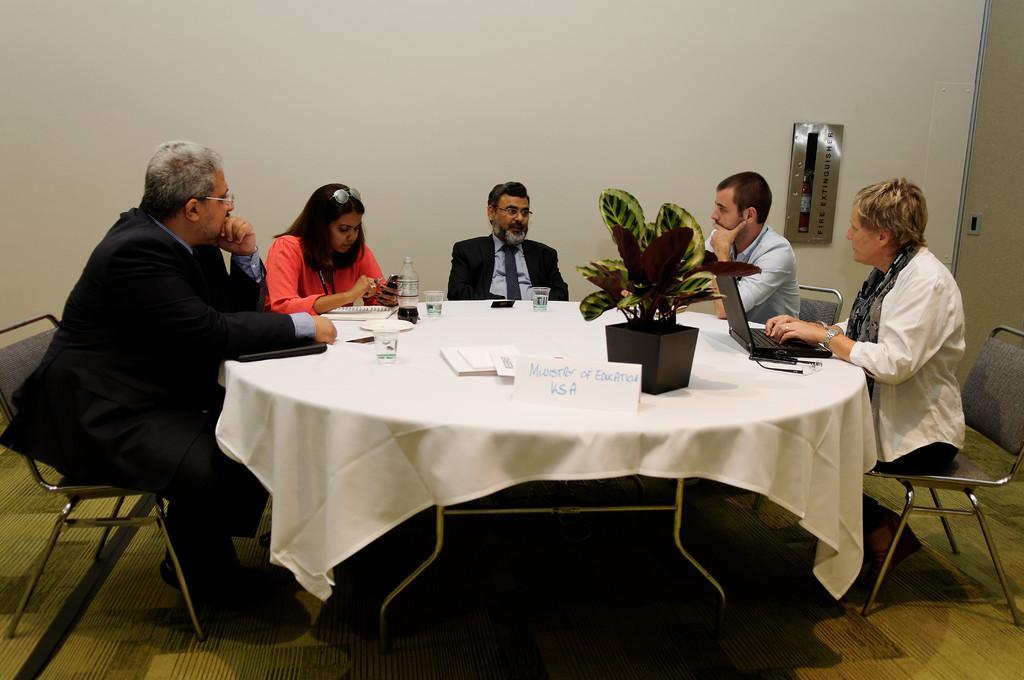Please provide a concise description of this image. The image is inside the room. In the image there are group of people sitting on chair in front of a table, on table we can see a cloth,book,bottle,glass of water and a laptop,flower pot ,plant. In background there is a wall which is in white color. 